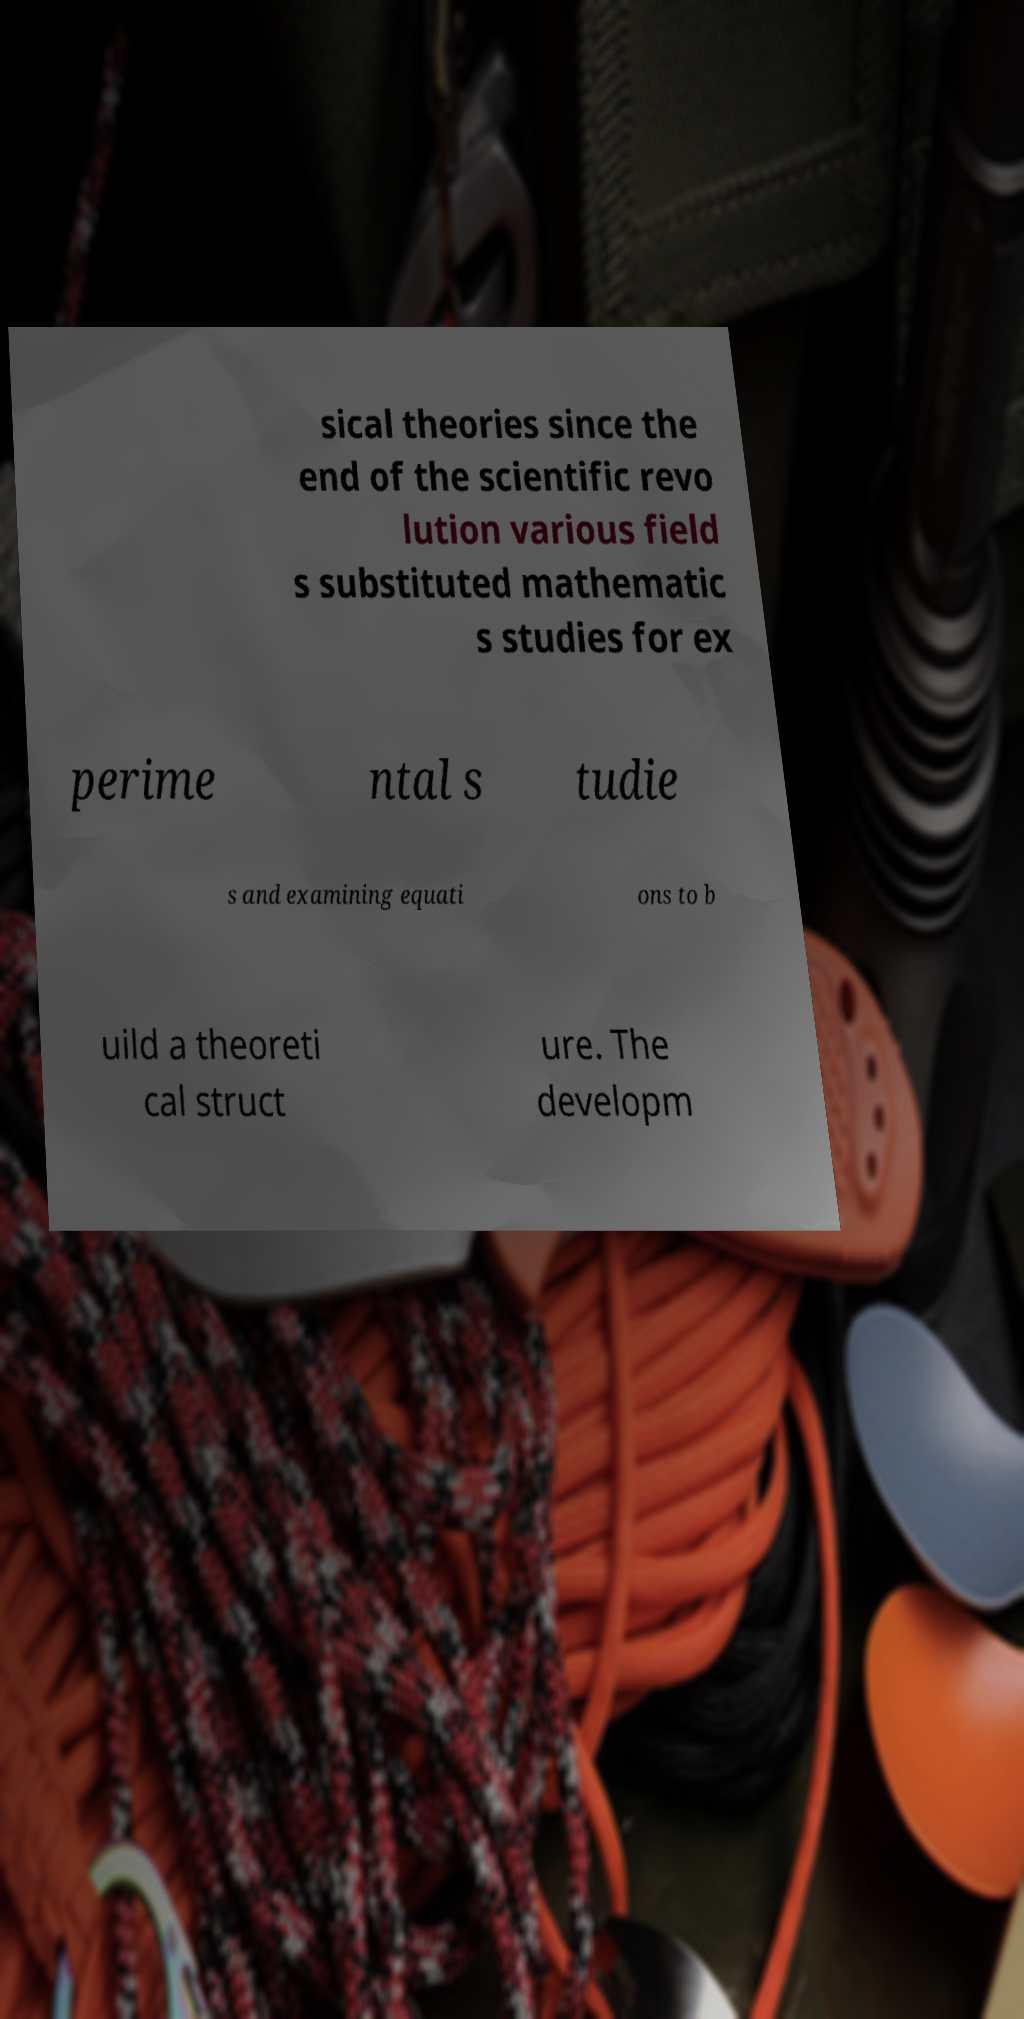I need the written content from this picture converted into text. Can you do that? sical theories since the end of the scientific revo lution various field s substituted mathematic s studies for ex perime ntal s tudie s and examining equati ons to b uild a theoreti cal struct ure. The developm 